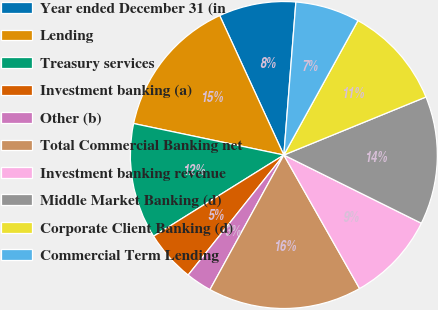Convert chart. <chart><loc_0><loc_0><loc_500><loc_500><pie_chart><fcel>Year ended December 31 (in<fcel>Lending<fcel>Treasury services<fcel>Investment banking (a)<fcel>Other (b)<fcel>Total Commercial Banking net<fcel>Investment banking revenue<fcel>Middle Market Banking (d)<fcel>Corporate Client Banking (d)<fcel>Commercial Term Lending<nl><fcel>8.11%<fcel>14.85%<fcel>12.16%<fcel>5.42%<fcel>2.72%<fcel>16.2%<fcel>9.46%<fcel>13.5%<fcel>10.81%<fcel>6.77%<nl></chart> 